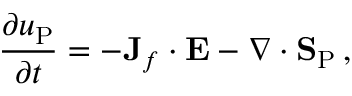<formula> <loc_0><loc_0><loc_500><loc_500>\frac { \partial u _ { P } } { \partial t } = - { J } _ { f } \cdot { E } - \nabla \cdot { S } _ { P } \, ,</formula> 